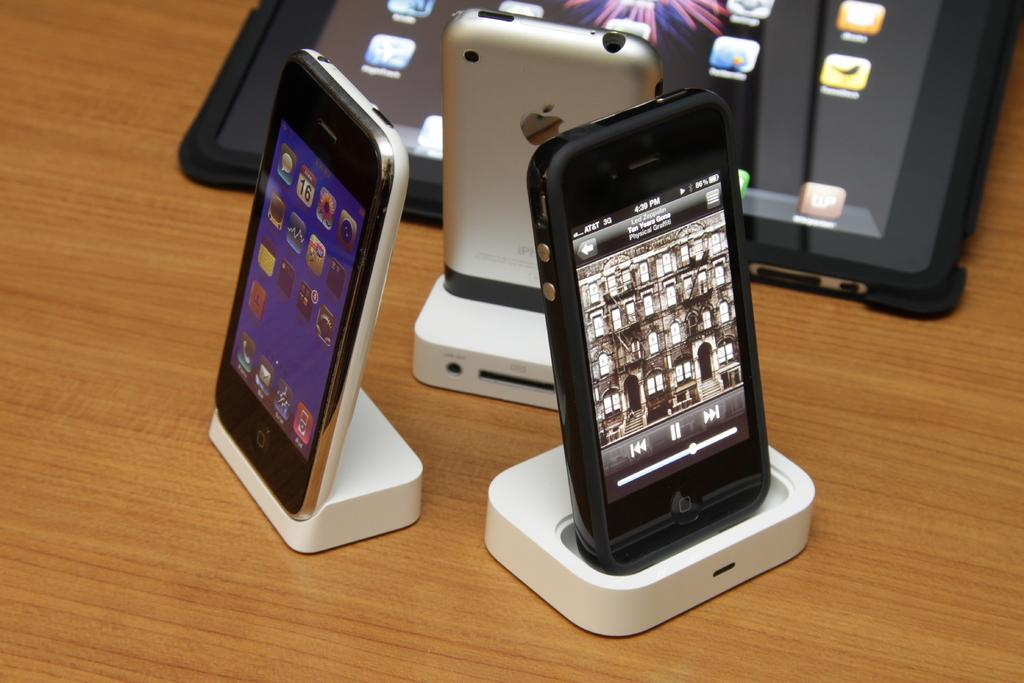Provide a one-sentence caption for the provided image. A phone is turned on with a time of 4:39 showing on the screen. 